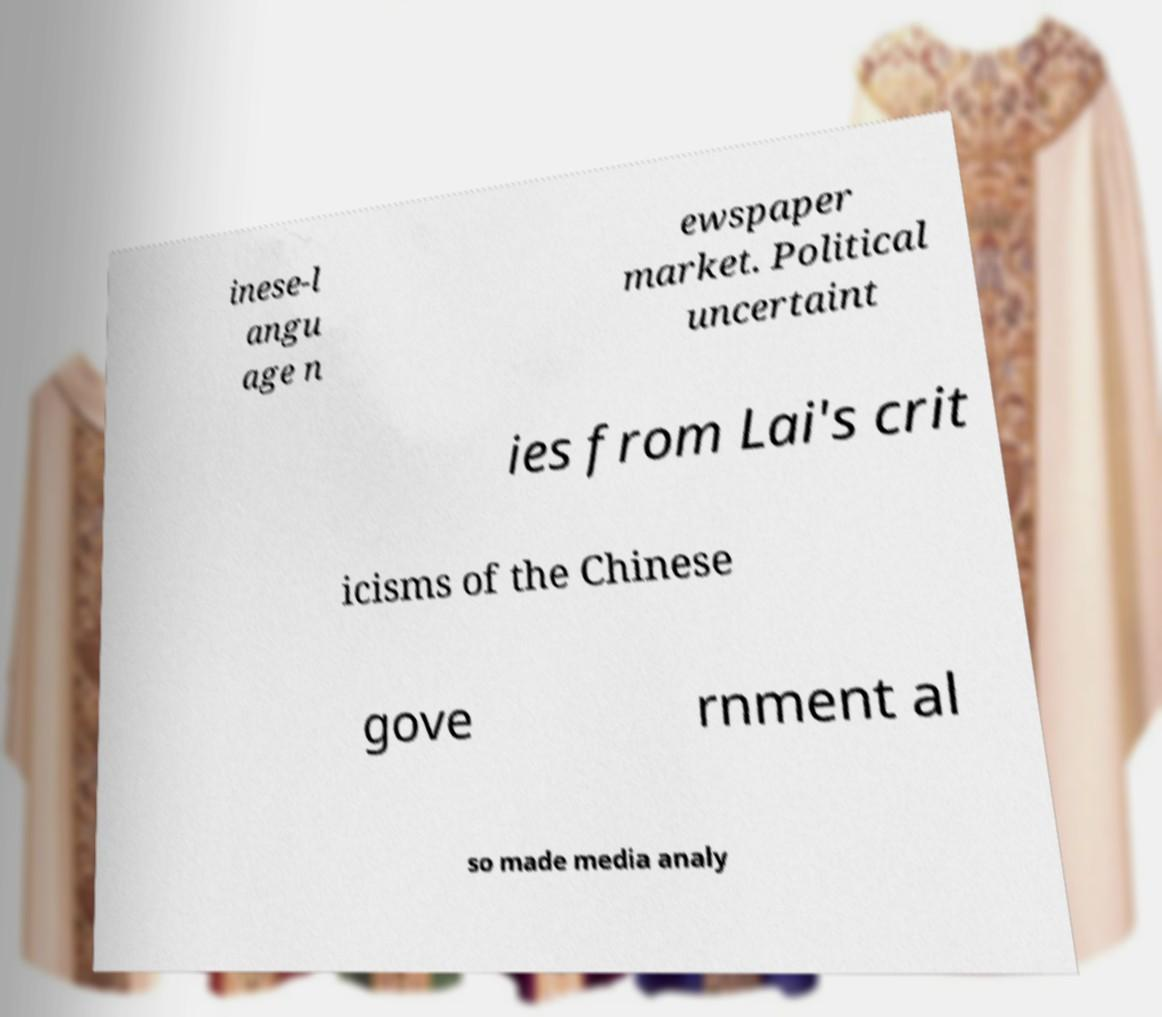Can you accurately transcribe the text from the provided image for me? inese-l angu age n ewspaper market. Political uncertaint ies from Lai's crit icisms of the Chinese gove rnment al so made media analy 